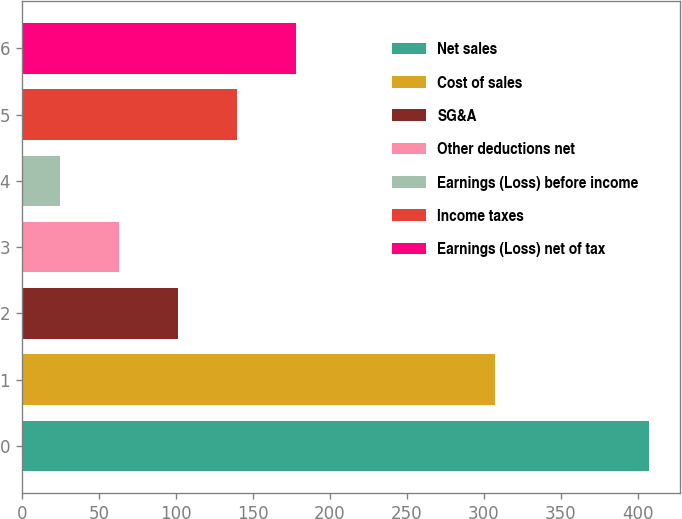Convert chart to OTSL. <chart><loc_0><loc_0><loc_500><loc_500><bar_chart><fcel>Net sales<fcel>Cost of sales<fcel>SG&A<fcel>Other deductions net<fcel>Earnings (Loss) before income<fcel>Income taxes<fcel>Earnings (Loss) net of tax<nl><fcel>407<fcel>307<fcel>101.4<fcel>63.2<fcel>25<fcel>139.6<fcel>177.8<nl></chart> 